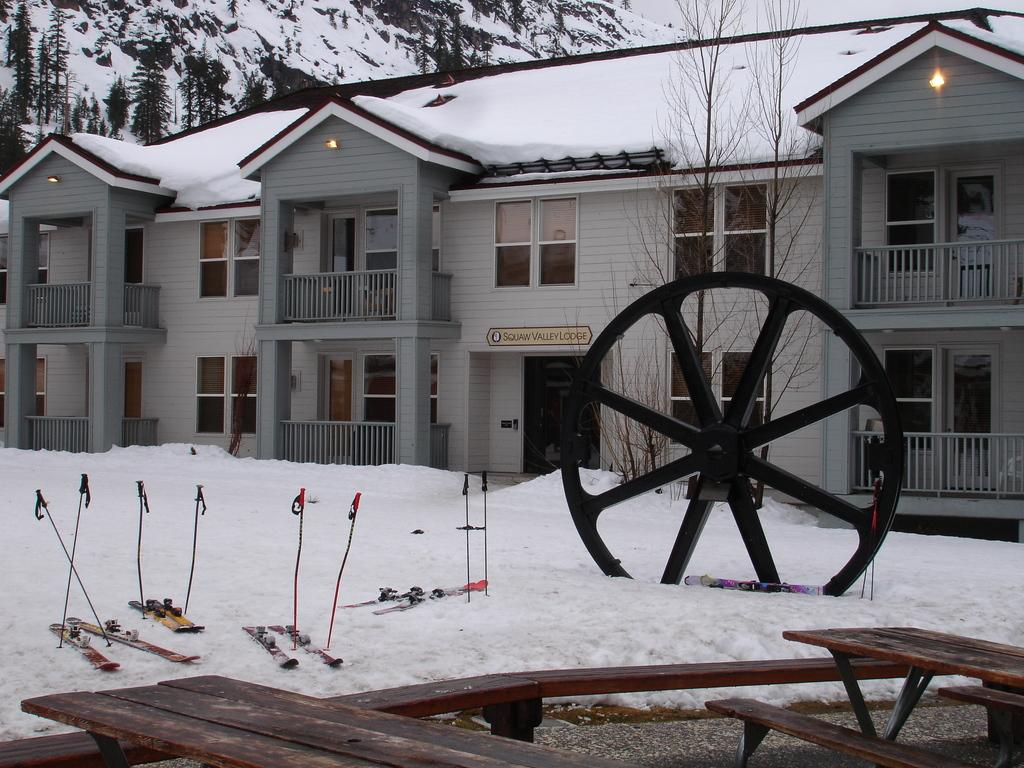What is the condition of the houses in the image? The houses are covered with snow in the image. What is the weather like outside the houses? There is a lot of snow outside the outside of the houses. What can be seen in the background of the image? There is a big wheel in the background of the image. What natural feature is visible in the image? There is a mountain visible in the image. What type of vegetation is present in the image? There are trees in the image. How many cats are playing with the army in the image? There are no cats or army present in the image; it features houses covered with snow, a big wheel, a mountain, and trees. 